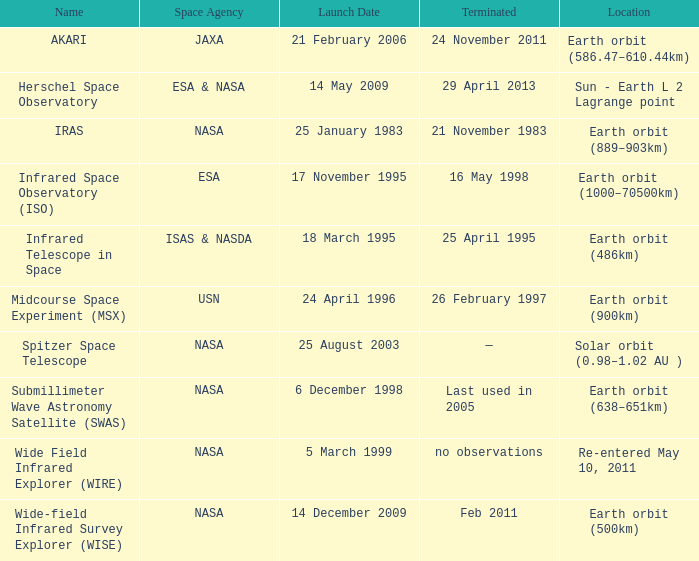Which space agency deployed the herschel space observatory? ESA & NASA. 